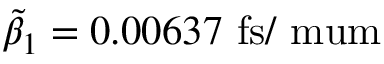Convert formula to latex. <formula><loc_0><loc_0><loc_500><loc_500>\tilde { \beta } _ { 1 } = 0 . 0 0 6 3 7 f s / \ m u m</formula> 